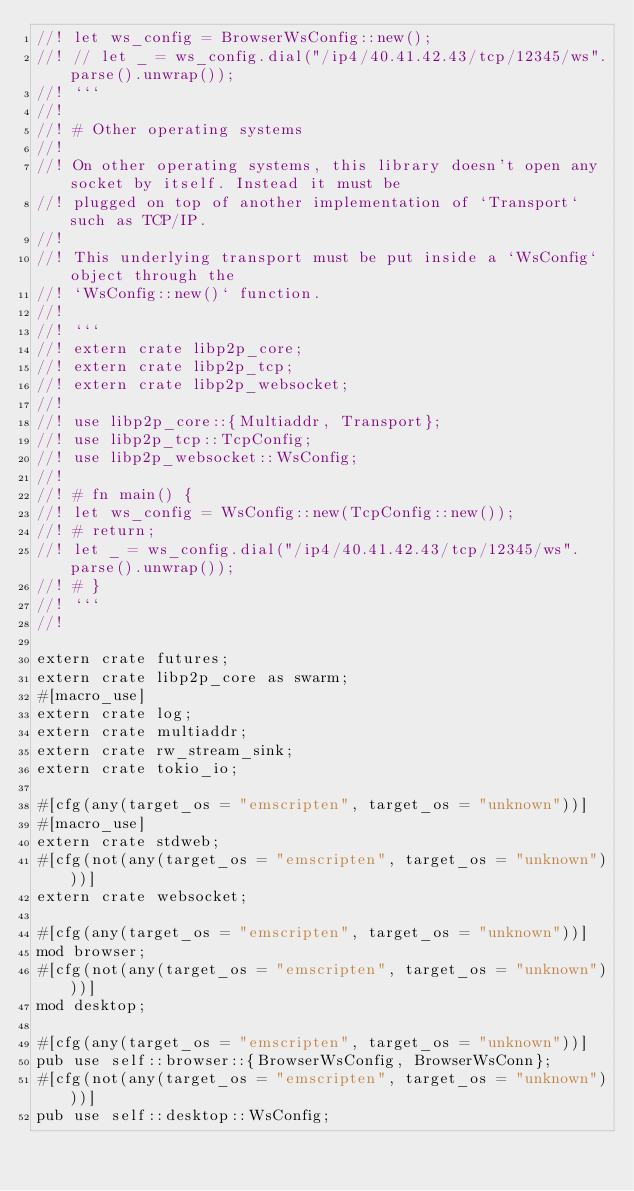<code> <loc_0><loc_0><loc_500><loc_500><_Rust_>//! let ws_config = BrowserWsConfig::new();
//! // let _ = ws_config.dial("/ip4/40.41.42.43/tcp/12345/ws".parse().unwrap());
//! ```
//!
//! # Other operating systems
//!
//! On other operating systems, this library doesn't open any socket by itself. Instead it must be
//! plugged on top of another implementation of `Transport` such as TCP/IP.
//!
//! This underlying transport must be put inside a `WsConfig` object through the
//! `WsConfig::new()` function.
//!
//! ```
//! extern crate libp2p_core;
//! extern crate libp2p_tcp;
//! extern crate libp2p_websocket;
//!
//! use libp2p_core::{Multiaddr, Transport};
//! use libp2p_tcp::TcpConfig;
//! use libp2p_websocket::WsConfig;
//!
//! # fn main() {
//! let ws_config = WsConfig::new(TcpConfig::new());
//! # return;
//! let _ = ws_config.dial("/ip4/40.41.42.43/tcp/12345/ws".parse().unwrap());
//! # }
//! ```
//!

extern crate futures;
extern crate libp2p_core as swarm;
#[macro_use]
extern crate log;
extern crate multiaddr;
extern crate rw_stream_sink;
extern crate tokio_io;

#[cfg(any(target_os = "emscripten", target_os = "unknown"))]
#[macro_use]
extern crate stdweb;
#[cfg(not(any(target_os = "emscripten", target_os = "unknown")))]
extern crate websocket;

#[cfg(any(target_os = "emscripten", target_os = "unknown"))]
mod browser;
#[cfg(not(any(target_os = "emscripten", target_os = "unknown")))]
mod desktop;

#[cfg(any(target_os = "emscripten", target_os = "unknown"))]
pub use self::browser::{BrowserWsConfig, BrowserWsConn};
#[cfg(not(any(target_os = "emscripten", target_os = "unknown")))]
pub use self::desktop::WsConfig;
</code> 